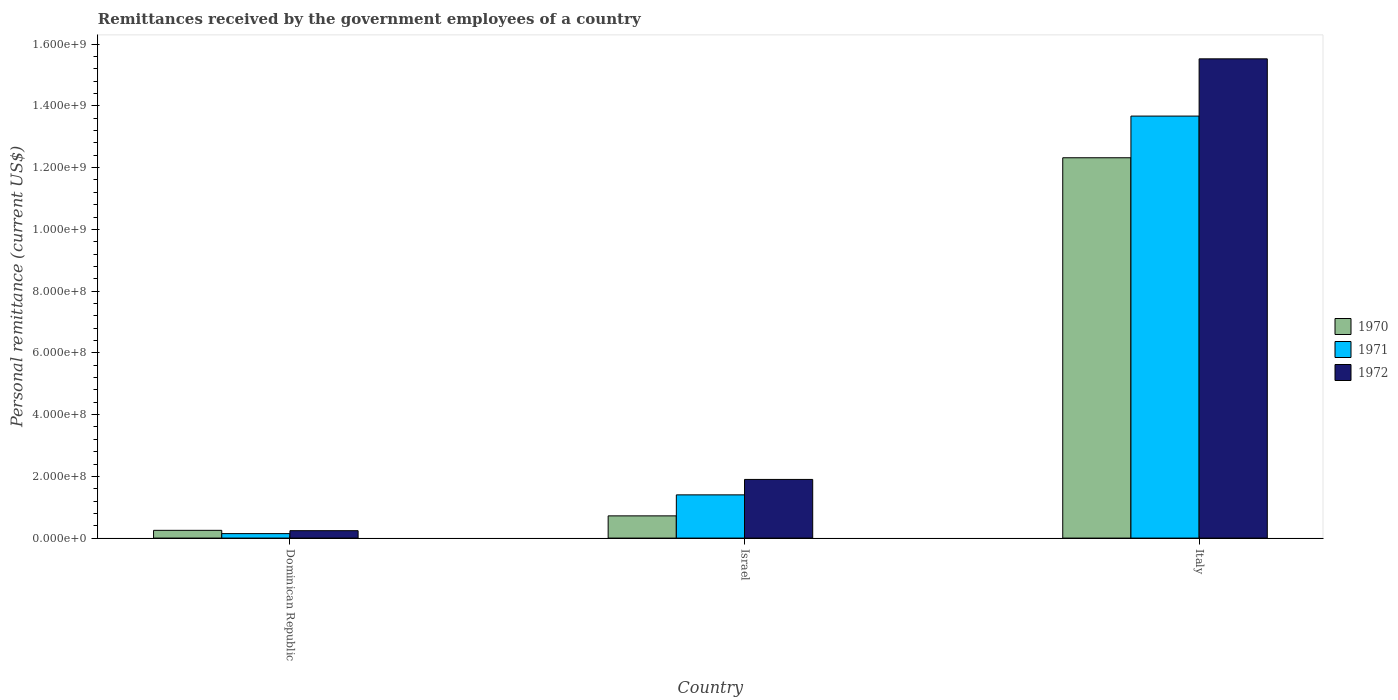How many different coloured bars are there?
Make the answer very short. 3. Are the number of bars per tick equal to the number of legend labels?
Your answer should be compact. Yes. Are the number of bars on each tick of the X-axis equal?
Offer a very short reply. Yes. How many bars are there on the 3rd tick from the right?
Give a very brief answer. 3. What is the remittances received by the government employees in 1972 in Italy?
Offer a terse response. 1.55e+09. Across all countries, what is the maximum remittances received by the government employees in 1971?
Your answer should be very brief. 1.37e+09. Across all countries, what is the minimum remittances received by the government employees in 1972?
Your answer should be compact. 2.40e+07. In which country was the remittances received by the government employees in 1971 minimum?
Your answer should be compact. Dominican Republic. What is the total remittances received by the government employees in 1971 in the graph?
Offer a very short reply. 1.52e+09. What is the difference between the remittances received by the government employees in 1971 in Dominican Republic and that in Italy?
Provide a succinct answer. -1.35e+09. What is the difference between the remittances received by the government employees in 1970 in Italy and the remittances received by the government employees in 1971 in Dominican Republic?
Make the answer very short. 1.22e+09. What is the average remittances received by the government employees in 1970 per country?
Make the answer very short. 4.43e+08. What is the difference between the remittances received by the government employees of/in 1971 and remittances received by the government employees of/in 1972 in Italy?
Offer a very short reply. -1.85e+08. What is the ratio of the remittances received by the government employees in 1970 in Dominican Republic to that in Israel?
Offer a terse response. 0.35. Is the remittances received by the government employees in 1971 in Dominican Republic less than that in Italy?
Your answer should be compact. Yes. Is the difference between the remittances received by the government employees in 1971 in Israel and Italy greater than the difference between the remittances received by the government employees in 1972 in Israel and Italy?
Ensure brevity in your answer.  Yes. What is the difference between the highest and the second highest remittances received by the government employees in 1970?
Offer a terse response. 1.16e+09. What is the difference between the highest and the lowest remittances received by the government employees in 1972?
Provide a short and direct response. 1.53e+09. Is the sum of the remittances received by the government employees in 1972 in Dominican Republic and Italy greater than the maximum remittances received by the government employees in 1970 across all countries?
Your answer should be very brief. Yes. What does the 1st bar from the left in Israel represents?
Provide a short and direct response. 1970. What does the 2nd bar from the right in Dominican Republic represents?
Provide a short and direct response. 1971. Is it the case that in every country, the sum of the remittances received by the government employees in 1970 and remittances received by the government employees in 1972 is greater than the remittances received by the government employees in 1971?
Offer a very short reply. Yes. How many bars are there?
Your response must be concise. 9. Are all the bars in the graph horizontal?
Provide a short and direct response. No. How many countries are there in the graph?
Provide a succinct answer. 3. Where does the legend appear in the graph?
Provide a short and direct response. Center right. How many legend labels are there?
Make the answer very short. 3. How are the legend labels stacked?
Offer a very short reply. Vertical. What is the title of the graph?
Provide a succinct answer. Remittances received by the government employees of a country. Does "2002" appear as one of the legend labels in the graph?
Keep it short and to the point. No. What is the label or title of the X-axis?
Offer a terse response. Country. What is the label or title of the Y-axis?
Keep it short and to the point. Personal remittance (current US$). What is the Personal remittance (current US$) of 1970 in Dominican Republic?
Keep it short and to the point. 2.51e+07. What is the Personal remittance (current US$) in 1971 in Dominican Republic?
Keep it short and to the point. 1.45e+07. What is the Personal remittance (current US$) of 1972 in Dominican Republic?
Your answer should be compact. 2.40e+07. What is the Personal remittance (current US$) of 1970 in Israel?
Give a very brief answer. 7.20e+07. What is the Personal remittance (current US$) of 1971 in Israel?
Make the answer very short. 1.40e+08. What is the Personal remittance (current US$) of 1972 in Israel?
Provide a succinct answer. 1.90e+08. What is the Personal remittance (current US$) in 1970 in Italy?
Provide a short and direct response. 1.23e+09. What is the Personal remittance (current US$) in 1971 in Italy?
Ensure brevity in your answer.  1.37e+09. What is the Personal remittance (current US$) in 1972 in Italy?
Provide a short and direct response. 1.55e+09. Across all countries, what is the maximum Personal remittance (current US$) of 1970?
Your response must be concise. 1.23e+09. Across all countries, what is the maximum Personal remittance (current US$) in 1971?
Your answer should be very brief. 1.37e+09. Across all countries, what is the maximum Personal remittance (current US$) in 1972?
Your answer should be compact. 1.55e+09. Across all countries, what is the minimum Personal remittance (current US$) in 1970?
Give a very brief answer. 2.51e+07. Across all countries, what is the minimum Personal remittance (current US$) in 1971?
Offer a very short reply. 1.45e+07. Across all countries, what is the minimum Personal remittance (current US$) of 1972?
Give a very brief answer. 2.40e+07. What is the total Personal remittance (current US$) in 1970 in the graph?
Make the answer very short. 1.33e+09. What is the total Personal remittance (current US$) of 1971 in the graph?
Your response must be concise. 1.52e+09. What is the total Personal remittance (current US$) of 1972 in the graph?
Ensure brevity in your answer.  1.77e+09. What is the difference between the Personal remittance (current US$) of 1970 in Dominican Republic and that in Israel?
Offer a terse response. -4.69e+07. What is the difference between the Personal remittance (current US$) of 1971 in Dominican Republic and that in Israel?
Provide a short and direct response. -1.26e+08. What is the difference between the Personal remittance (current US$) in 1972 in Dominican Republic and that in Israel?
Your answer should be very brief. -1.66e+08. What is the difference between the Personal remittance (current US$) in 1970 in Dominican Republic and that in Italy?
Your answer should be compact. -1.21e+09. What is the difference between the Personal remittance (current US$) of 1971 in Dominican Republic and that in Italy?
Ensure brevity in your answer.  -1.35e+09. What is the difference between the Personal remittance (current US$) of 1972 in Dominican Republic and that in Italy?
Make the answer very short. -1.53e+09. What is the difference between the Personal remittance (current US$) of 1970 in Israel and that in Italy?
Provide a succinct answer. -1.16e+09. What is the difference between the Personal remittance (current US$) in 1971 in Israel and that in Italy?
Your answer should be compact. -1.23e+09. What is the difference between the Personal remittance (current US$) of 1972 in Israel and that in Italy?
Provide a succinct answer. -1.36e+09. What is the difference between the Personal remittance (current US$) in 1970 in Dominican Republic and the Personal remittance (current US$) in 1971 in Israel?
Your response must be concise. -1.15e+08. What is the difference between the Personal remittance (current US$) of 1970 in Dominican Republic and the Personal remittance (current US$) of 1972 in Israel?
Provide a succinct answer. -1.65e+08. What is the difference between the Personal remittance (current US$) in 1971 in Dominican Republic and the Personal remittance (current US$) in 1972 in Israel?
Offer a very short reply. -1.76e+08. What is the difference between the Personal remittance (current US$) in 1970 in Dominican Republic and the Personal remittance (current US$) in 1971 in Italy?
Offer a very short reply. -1.34e+09. What is the difference between the Personal remittance (current US$) in 1970 in Dominican Republic and the Personal remittance (current US$) in 1972 in Italy?
Keep it short and to the point. -1.53e+09. What is the difference between the Personal remittance (current US$) in 1971 in Dominican Republic and the Personal remittance (current US$) in 1972 in Italy?
Offer a terse response. -1.54e+09. What is the difference between the Personal remittance (current US$) in 1970 in Israel and the Personal remittance (current US$) in 1971 in Italy?
Offer a very short reply. -1.30e+09. What is the difference between the Personal remittance (current US$) of 1970 in Israel and the Personal remittance (current US$) of 1972 in Italy?
Keep it short and to the point. -1.48e+09. What is the difference between the Personal remittance (current US$) of 1971 in Israel and the Personal remittance (current US$) of 1972 in Italy?
Provide a succinct answer. -1.41e+09. What is the average Personal remittance (current US$) in 1970 per country?
Give a very brief answer. 4.43e+08. What is the average Personal remittance (current US$) in 1971 per country?
Give a very brief answer. 5.07e+08. What is the average Personal remittance (current US$) of 1972 per country?
Keep it short and to the point. 5.89e+08. What is the difference between the Personal remittance (current US$) of 1970 and Personal remittance (current US$) of 1971 in Dominican Republic?
Give a very brief answer. 1.06e+07. What is the difference between the Personal remittance (current US$) in 1970 and Personal remittance (current US$) in 1972 in Dominican Republic?
Your response must be concise. 1.10e+06. What is the difference between the Personal remittance (current US$) in 1971 and Personal remittance (current US$) in 1972 in Dominican Republic?
Keep it short and to the point. -9.50e+06. What is the difference between the Personal remittance (current US$) of 1970 and Personal remittance (current US$) of 1971 in Israel?
Give a very brief answer. -6.80e+07. What is the difference between the Personal remittance (current US$) of 1970 and Personal remittance (current US$) of 1972 in Israel?
Provide a short and direct response. -1.18e+08. What is the difference between the Personal remittance (current US$) of 1971 and Personal remittance (current US$) of 1972 in Israel?
Provide a short and direct response. -5.00e+07. What is the difference between the Personal remittance (current US$) of 1970 and Personal remittance (current US$) of 1971 in Italy?
Provide a short and direct response. -1.35e+08. What is the difference between the Personal remittance (current US$) in 1970 and Personal remittance (current US$) in 1972 in Italy?
Give a very brief answer. -3.20e+08. What is the difference between the Personal remittance (current US$) in 1971 and Personal remittance (current US$) in 1972 in Italy?
Keep it short and to the point. -1.85e+08. What is the ratio of the Personal remittance (current US$) of 1970 in Dominican Republic to that in Israel?
Your answer should be compact. 0.35. What is the ratio of the Personal remittance (current US$) of 1971 in Dominican Republic to that in Israel?
Offer a terse response. 0.1. What is the ratio of the Personal remittance (current US$) of 1972 in Dominican Republic to that in Israel?
Offer a very short reply. 0.13. What is the ratio of the Personal remittance (current US$) of 1970 in Dominican Republic to that in Italy?
Make the answer very short. 0.02. What is the ratio of the Personal remittance (current US$) of 1971 in Dominican Republic to that in Italy?
Provide a short and direct response. 0.01. What is the ratio of the Personal remittance (current US$) in 1972 in Dominican Republic to that in Italy?
Offer a very short reply. 0.02. What is the ratio of the Personal remittance (current US$) of 1970 in Israel to that in Italy?
Provide a short and direct response. 0.06. What is the ratio of the Personal remittance (current US$) of 1971 in Israel to that in Italy?
Keep it short and to the point. 0.1. What is the ratio of the Personal remittance (current US$) of 1972 in Israel to that in Italy?
Provide a short and direct response. 0.12. What is the difference between the highest and the second highest Personal remittance (current US$) in 1970?
Your answer should be very brief. 1.16e+09. What is the difference between the highest and the second highest Personal remittance (current US$) in 1971?
Provide a short and direct response. 1.23e+09. What is the difference between the highest and the second highest Personal remittance (current US$) in 1972?
Ensure brevity in your answer.  1.36e+09. What is the difference between the highest and the lowest Personal remittance (current US$) of 1970?
Provide a short and direct response. 1.21e+09. What is the difference between the highest and the lowest Personal remittance (current US$) in 1971?
Offer a terse response. 1.35e+09. What is the difference between the highest and the lowest Personal remittance (current US$) in 1972?
Provide a succinct answer. 1.53e+09. 